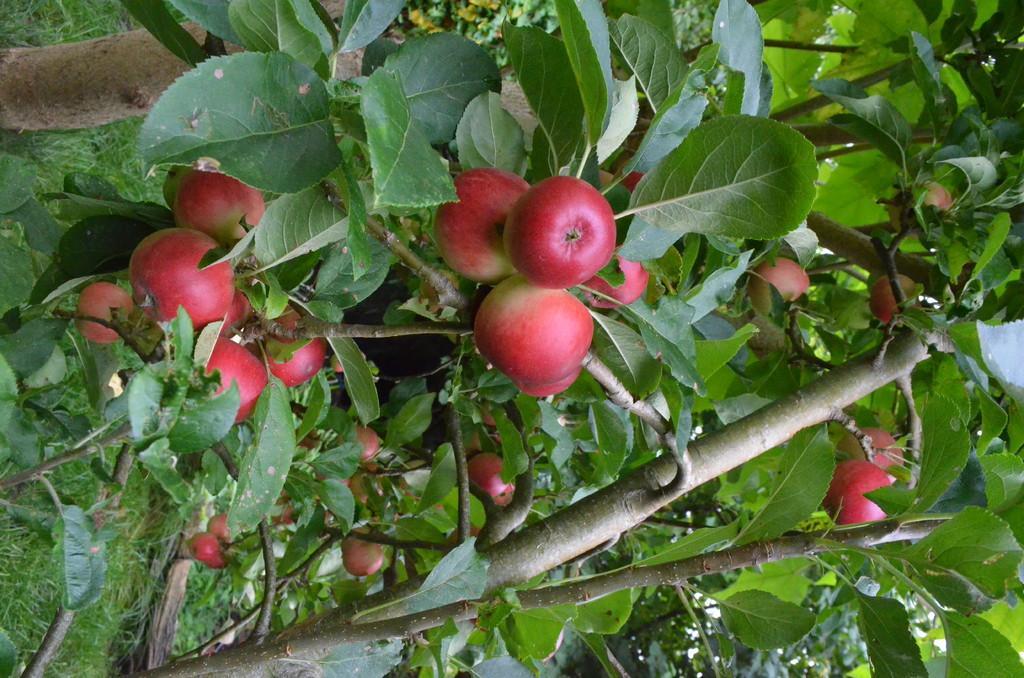Please provide a concise description of this image. In this image we can see group of fruits and leaves on branches of trees. In the background, we can see the grass. 